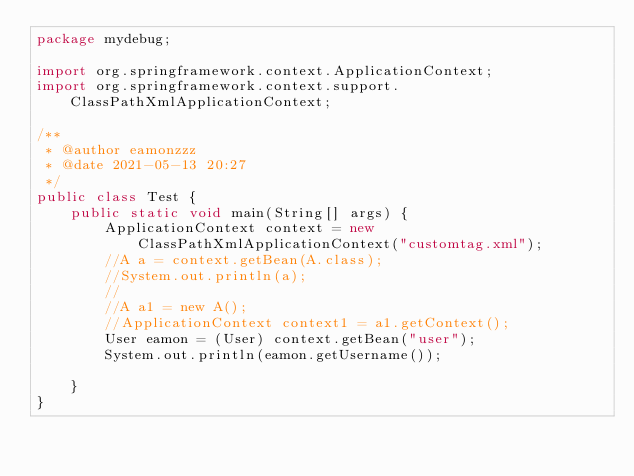Convert code to text. <code><loc_0><loc_0><loc_500><loc_500><_Java_>package mydebug;

import org.springframework.context.ApplicationContext;
import org.springframework.context.support.ClassPathXmlApplicationContext;

/**
 * @author eamonzzz
 * @date 2021-05-13 20:27
 */
public class Test {
	public static void main(String[] args) {
		ApplicationContext context = new ClassPathXmlApplicationContext("customtag.xml");
		//A a = context.getBean(A.class);
		//System.out.println(a);
		//
		//A a1 = new A();
		//ApplicationContext context1 = a1.getContext();
		User eamon = (User) context.getBean("user");
		System.out.println(eamon.getUsername());

	}
}
</code> 